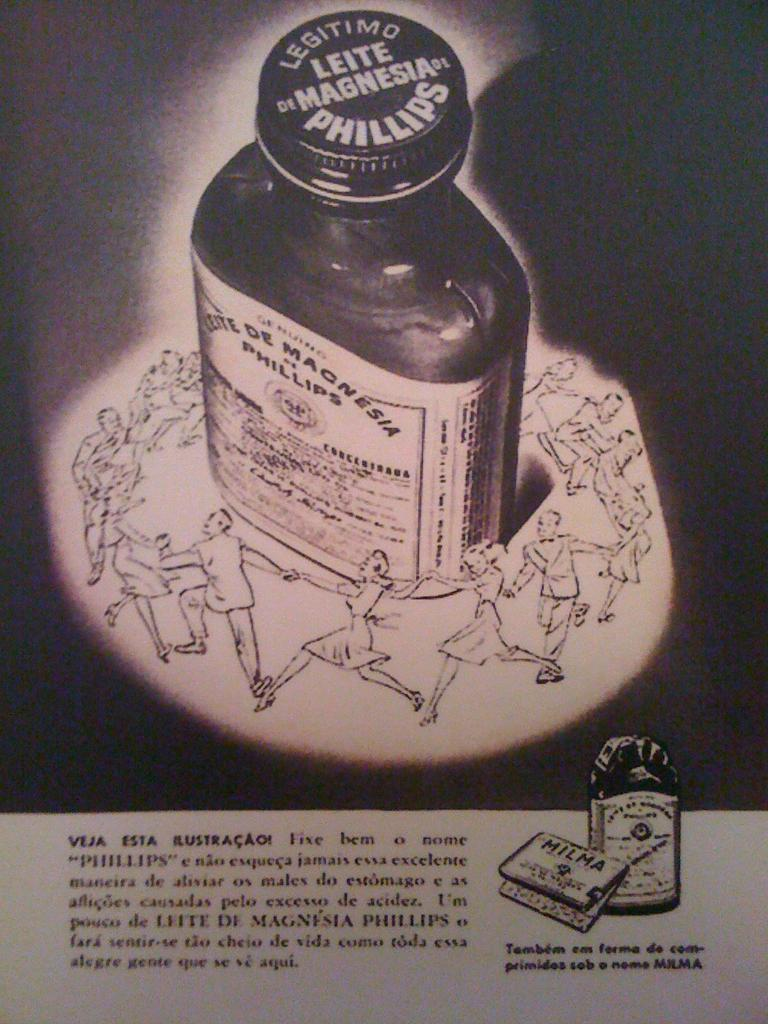<image>
Offer a succinct explanation of the picture presented. Men and women dance in a circle around a bottle of Leite de Magnesia. 